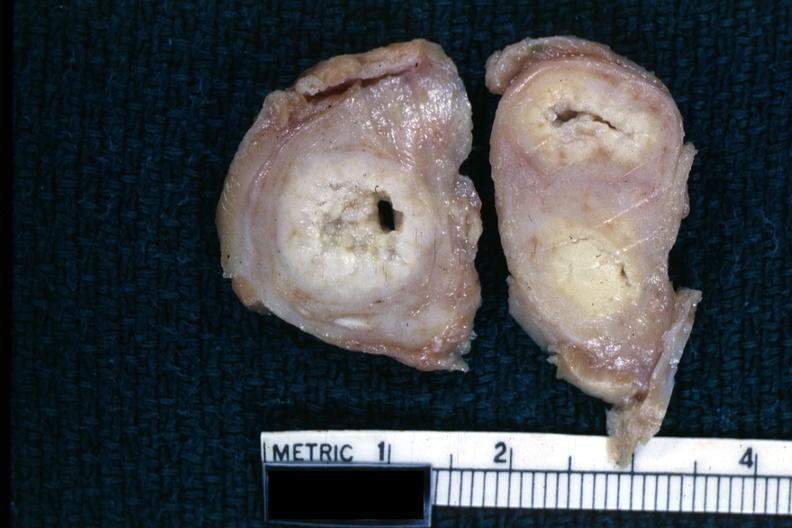where does this part belong to?
Answer the question using a single word or phrase. Female reproductive system 